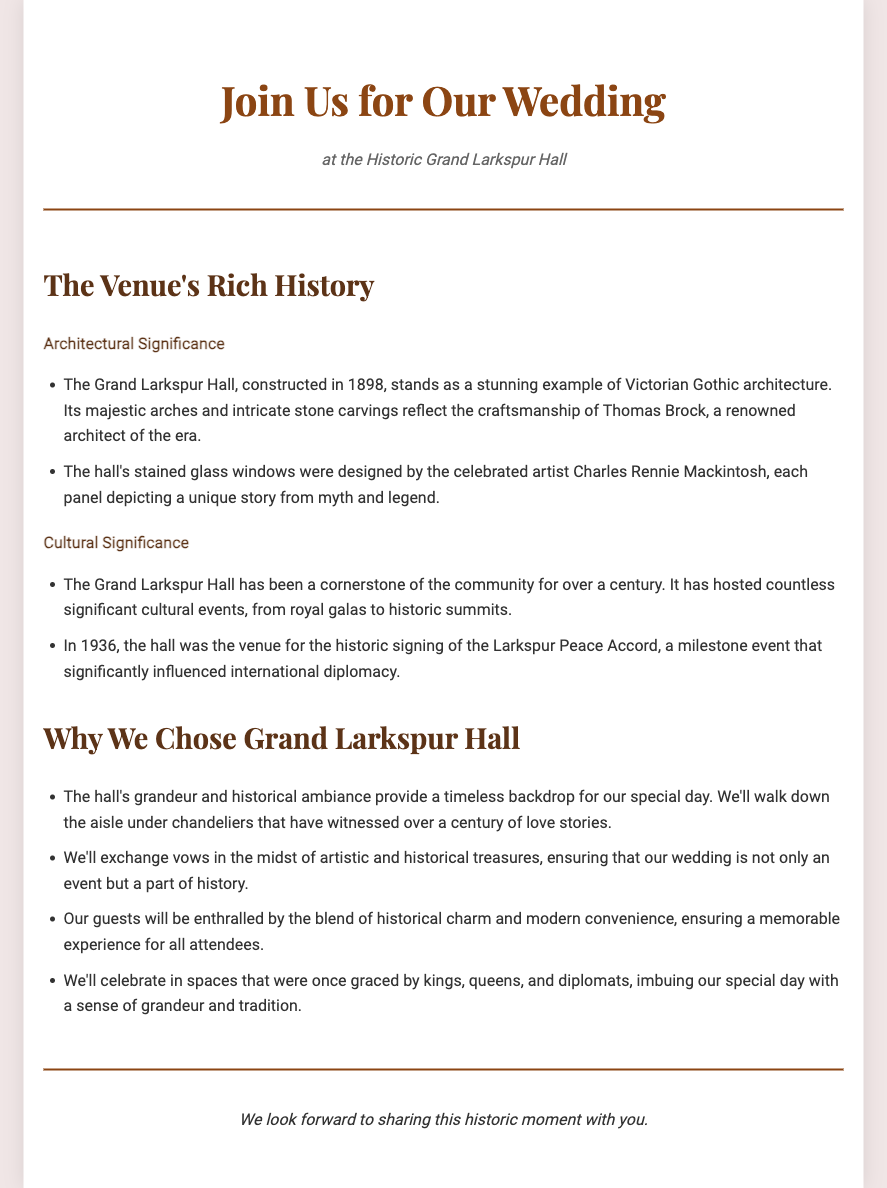What year was Grand Larkspur Hall constructed? The document states that the Grand Larkspur Hall was constructed in 1898.
Answer: 1898 Who was the architect of Grand Larkspur Hall? The architect associated with the construction of Grand Larkspur Hall is Thomas Brock, mentioned in the architectural details.
Answer: Thomas Brock What style of architecture does Grand Larkspur Hall represent? The document describes Grand Larkspur Hall as a stunning example of Victorian Gothic architecture.
Answer: Victorian Gothic What significant event took place at Grand Larkspur Hall in 1936? The historic signing of the Larkspur Peace Accord occurred at Grand Larkspur Hall in 1936, as noted in the cultural significance section.
Answer: Larkspur Peace Accord What unique feature did the stained glass windows have? The stained glass windows were designed by celebrated artist Charles Rennie Mackintosh, reflecting unique stories from myth and legend.
Answer: Unique stories from myth and legend Why did the couple choose Grand Larkspur Hall for their wedding? The couple chose Grand Larkspur Hall for its grandeur and historical ambiance, providing a timeless backdrop for their wedding.
Answer: Grandeur and historical ambiance How many years has Grand Larkspur Hall been a cornerstone of the community? It has been a cornerstone of the community for over a century, as mentioned in the document.
Answer: Over a century What were previously hosted at Grand Larkspur Hall? The hall hosted countless significant cultural events, including royal galas and historic summits, as specified in the cultural significance section.
Answer: Significant cultural events 